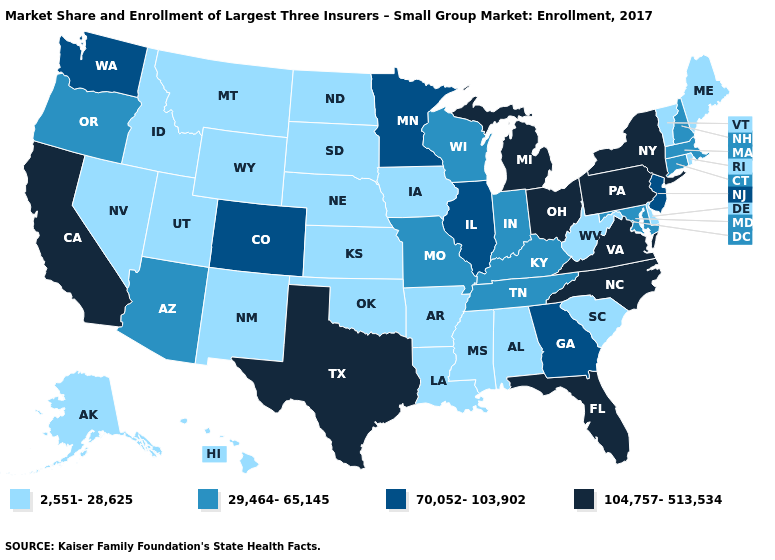Name the states that have a value in the range 104,757-513,534?
Give a very brief answer. California, Florida, Michigan, New York, North Carolina, Ohio, Pennsylvania, Texas, Virginia. Does Maine have a lower value than Florida?
Be succinct. Yes. Name the states that have a value in the range 70,052-103,902?
Quick response, please. Colorado, Georgia, Illinois, Minnesota, New Jersey, Washington. Does the first symbol in the legend represent the smallest category?
Write a very short answer. Yes. Name the states that have a value in the range 29,464-65,145?
Concise answer only. Arizona, Connecticut, Indiana, Kentucky, Maryland, Massachusetts, Missouri, New Hampshire, Oregon, Tennessee, Wisconsin. What is the value of Vermont?
Keep it brief. 2,551-28,625. Does South Dakota have a higher value than Texas?
Keep it brief. No. Name the states that have a value in the range 2,551-28,625?
Give a very brief answer. Alabama, Alaska, Arkansas, Delaware, Hawaii, Idaho, Iowa, Kansas, Louisiana, Maine, Mississippi, Montana, Nebraska, Nevada, New Mexico, North Dakota, Oklahoma, Rhode Island, South Carolina, South Dakota, Utah, Vermont, West Virginia, Wyoming. Does the first symbol in the legend represent the smallest category?
Give a very brief answer. Yes. Does Texas have the lowest value in the South?
Give a very brief answer. No. What is the highest value in the West ?
Give a very brief answer. 104,757-513,534. What is the lowest value in states that border Wisconsin?
Concise answer only. 2,551-28,625. Does West Virginia have the highest value in the USA?
Write a very short answer. No. Name the states that have a value in the range 2,551-28,625?
Quick response, please. Alabama, Alaska, Arkansas, Delaware, Hawaii, Idaho, Iowa, Kansas, Louisiana, Maine, Mississippi, Montana, Nebraska, Nevada, New Mexico, North Dakota, Oklahoma, Rhode Island, South Carolina, South Dakota, Utah, Vermont, West Virginia, Wyoming. Does New Mexico have the lowest value in the West?
Write a very short answer. Yes. 